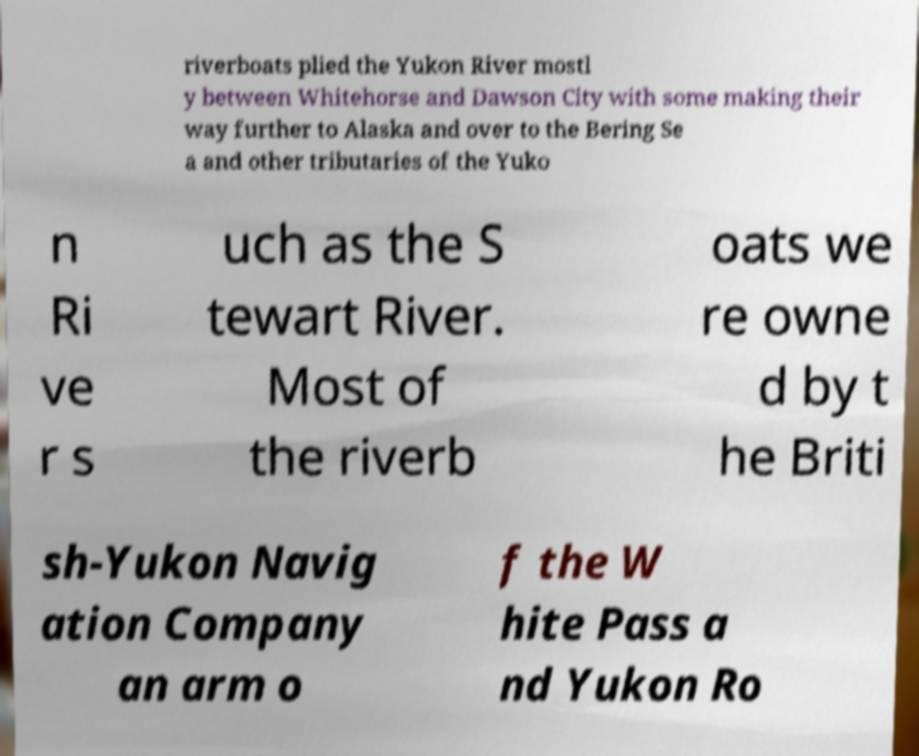Can you read and provide the text displayed in the image?This photo seems to have some interesting text. Can you extract and type it out for me? riverboats plied the Yukon River mostl y between Whitehorse and Dawson City with some making their way further to Alaska and over to the Bering Se a and other tributaries of the Yuko n Ri ve r s uch as the S tewart River. Most of the riverb oats we re owne d by t he Briti sh-Yukon Navig ation Company an arm o f the W hite Pass a nd Yukon Ro 